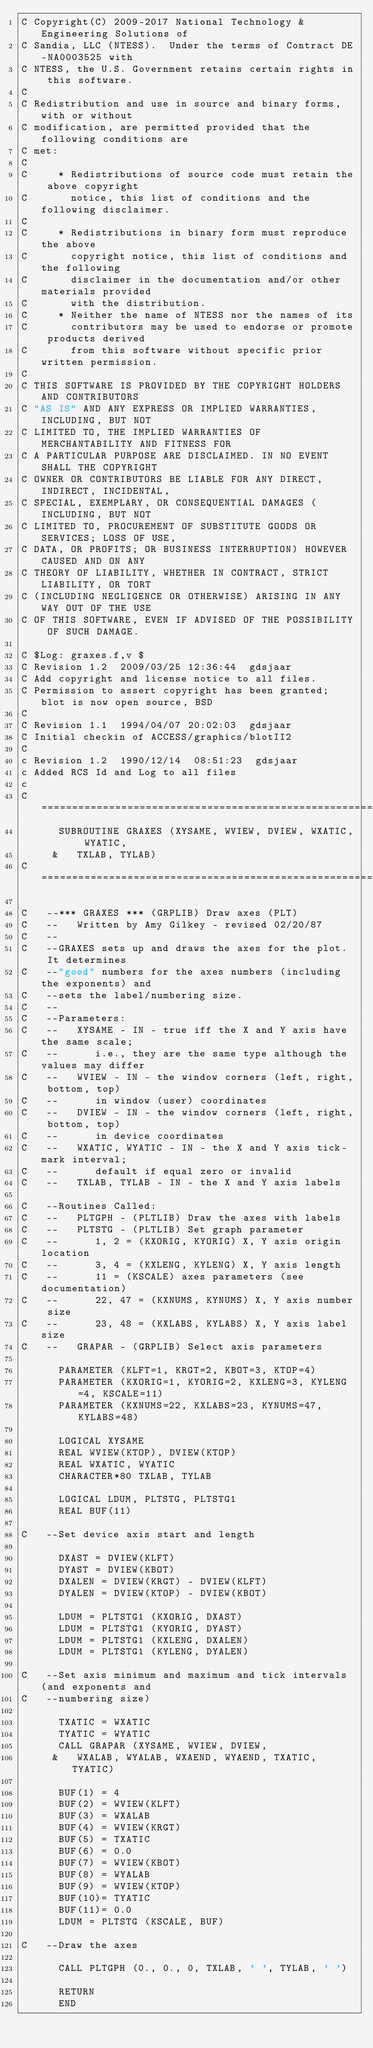<code> <loc_0><loc_0><loc_500><loc_500><_FORTRAN_>C Copyright(C) 2009-2017 National Technology & Engineering Solutions of
C Sandia, LLC (NTESS).  Under the terms of Contract DE-NA0003525 with
C NTESS, the U.S. Government retains certain rights in this software.
C
C Redistribution and use in source and binary forms, with or without
C modification, are permitted provided that the following conditions are
C met:
C
C     * Redistributions of source code must retain the above copyright
C       notice, this list of conditions and the following disclaimer.
C
C     * Redistributions in binary form must reproduce the above
C       copyright notice, this list of conditions and the following
C       disclaimer in the documentation and/or other materials provided
C       with the distribution.
C     * Neither the name of NTESS nor the names of its
C       contributors may be used to endorse or promote products derived
C       from this software without specific prior written permission.
C
C THIS SOFTWARE IS PROVIDED BY THE COPYRIGHT HOLDERS AND CONTRIBUTORS
C "AS IS" AND ANY EXPRESS OR IMPLIED WARRANTIES, INCLUDING, BUT NOT
C LIMITED TO, THE IMPLIED WARRANTIES OF MERCHANTABILITY AND FITNESS FOR
C A PARTICULAR PURPOSE ARE DISCLAIMED. IN NO EVENT SHALL THE COPYRIGHT
C OWNER OR CONTRIBUTORS BE LIABLE FOR ANY DIRECT, INDIRECT, INCIDENTAL,
C SPECIAL, EXEMPLARY, OR CONSEQUENTIAL DAMAGES (INCLUDING, BUT NOT
C LIMITED TO, PROCUREMENT OF SUBSTITUTE GOODS OR SERVICES; LOSS OF USE,
C DATA, OR PROFITS; OR BUSINESS INTERRUPTION) HOWEVER CAUSED AND ON ANY
C THEORY OF LIABILITY, WHETHER IN CONTRACT, STRICT LIABILITY, OR TORT
C (INCLUDING NEGLIGENCE OR OTHERWISE) ARISING IN ANY WAY OUT OF THE USE
C OF THIS SOFTWARE, EVEN IF ADVISED OF THE POSSIBILITY OF SUCH DAMAGE.

C $Log: graxes.f,v $
C Revision 1.2  2009/03/25 12:36:44  gdsjaar
C Add copyright and license notice to all files.
C Permission to assert copyright has been granted; blot is now open source, BSD
C
C Revision 1.1  1994/04/07 20:02:03  gdsjaar
C Initial checkin of ACCESS/graphics/blotII2
C
c Revision 1.2  1990/12/14  08:51:23  gdsjaar
c Added RCS Id and Log to all files
c
C=======================================================================
      SUBROUTINE GRAXES (XYSAME, WVIEW, DVIEW, WXATIC, WYATIC,
     &   TXLAB, TYLAB)
C=======================================================================

C   --*** GRAXES *** (GRPLIB) Draw axes (PLT)
C   --   Written by Amy Gilkey - revised 02/20/87
C   --
C   --GRAXES sets up and draws the axes for the plot.  It determines
C   --"good" numbers for the axes numbers (including the exponents) and
C   --sets the label/numbering size.
C   --
C   --Parameters:
C   --   XYSAME - IN - true iff the X and Y axis have the same scale;
C   --      i.e., they are the same type although the values may differ
C   --   WVIEW - IN - the window corners (left, right, bottom, top)
C   --      in window (user) coordinates
C   --   DVIEW - IN - the window corners (left, right, bottom, top)
C   --      in device coordinates
C   --   WXATIC, WYATIC - IN - the X and Y axis tick-mark interval;
C   --      default if equal zero or invalid
C   --   TXLAB, TYLAB - IN - the X and Y axis labels

C   --Routines Called:
C   --   PLTGPH - (PLTLIB) Draw the axes with labels
C   --   PLTSTG - (PLTLIB) Set graph parameter
C   --      1, 2 = (KXORIG, KYORIG) X, Y axis origin location
C   --      3, 4 = (KXLENG, KYLENG) X, Y axis length
C   --      11 = (KSCALE) axes parameters (see documentation)
C   --      22, 47 = (KXNUMS, KYNUMS) X, Y axis number size
C   --      23, 48 = (KXLABS, KYLABS) X, Y axis label size
C   --   GRAPAR - (GRPLIB) Select axis parameters

      PARAMETER (KLFT=1, KRGT=2, KBOT=3, KTOP=4)
      PARAMETER (KXORIG=1, KYORIG=2, KXLENG=3, KYLENG=4, KSCALE=11)
      PARAMETER (KXNUMS=22, KXLABS=23, KYNUMS=47, KYLABS=48)

      LOGICAL XYSAME
      REAL WVIEW(KTOP), DVIEW(KTOP)
      REAL WXATIC, WYATIC
      CHARACTER*80 TXLAB, TYLAB

      LOGICAL LDUM, PLTSTG, PLTSTG1
      REAL BUF(11)

C   --Set device axis start and length

      DXAST = DVIEW(KLFT)
      DYAST = DVIEW(KBOT)
      DXALEN = DVIEW(KRGT) - DVIEW(KLFT)
      DYALEN = DVIEW(KTOP) - DVIEW(KBOT)

      LDUM = PLTSTG1 (KXORIG, DXAST)
      LDUM = PLTSTG1 (KYORIG, DYAST)
      LDUM = PLTSTG1 (KXLENG, DXALEN)
      LDUM = PLTSTG1 (KYLENG, DYALEN)

C   --Set axis minimum and maximum and tick intervals (and exponents and
C   --numbering size)

      TXATIC = WXATIC
      TYATIC = WYATIC
      CALL GRAPAR (XYSAME, WVIEW, DVIEW,
     &   WXALAB, WYALAB, WXAEND, WYAEND, TXATIC, TYATIC)

      BUF(1) = 4
      BUF(2) = WVIEW(KLFT)
      BUF(3) = WXALAB
      BUF(4) = WVIEW(KRGT)
      BUF(5) = TXATIC
      BUF(6) = 0.0
      BUF(7) = WVIEW(KBOT)
      BUF(8) = WYALAB
      BUF(9) = WVIEW(KTOP)
      BUF(10)= TYATIC
      BUF(11)= 0.0
      LDUM = PLTSTG (KSCALE, BUF)

C   --Draw the axes

      CALL PLTGPH (0., 0., 0, TXLAB, ' ', TYLAB, ' ')

      RETURN
      END
</code> 